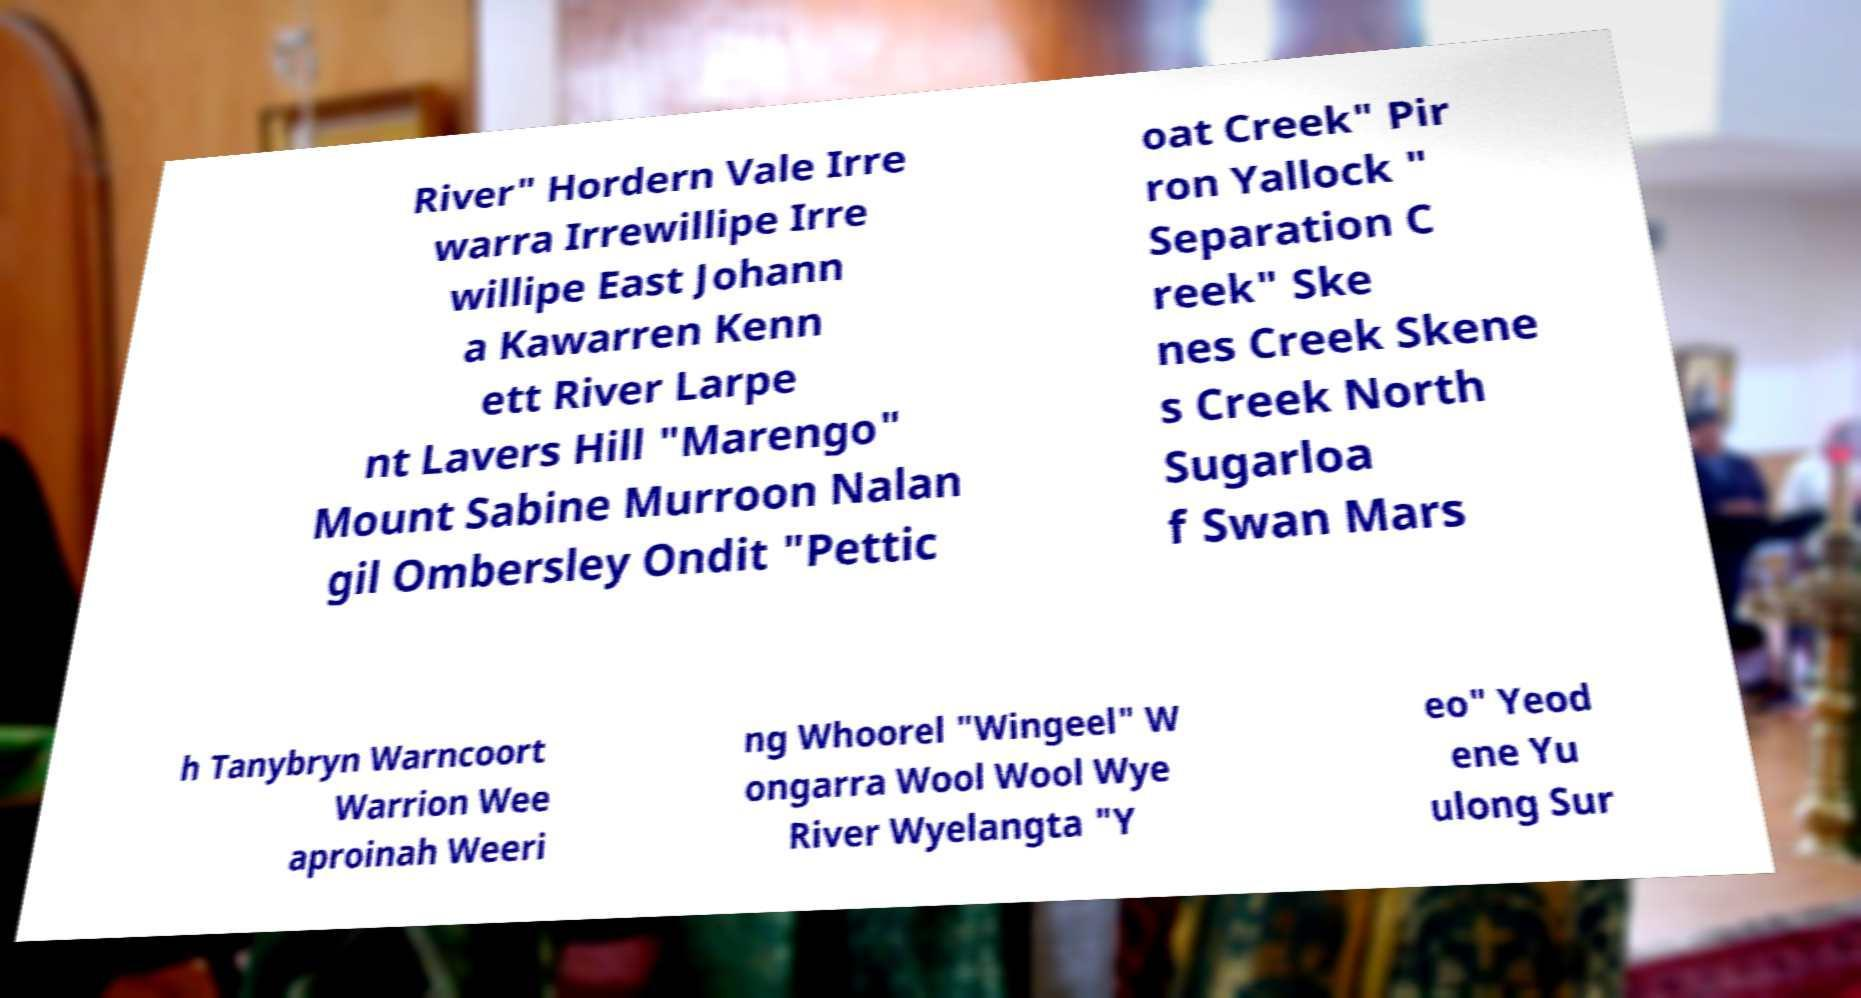Can you accurately transcribe the text from the provided image for me? River" Hordern Vale Irre warra Irrewillipe Irre willipe East Johann a Kawarren Kenn ett River Larpe nt Lavers Hill "Marengo" Mount Sabine Murroon Nalan gil Ombersley Ondit "Pettic oat Creek" Pir ron Yallock " Separation C reek" Ske nes Creek Skene s Creek North Sugarloa f Swan Mars h Tanybryn Warncoort Warrion Wee aproinah Weeri ng Whoorel "Wingeel" W ongarra Wool Wool Wye River Wyelangta "Y eo" Yeod ene Yu ulong Sur 